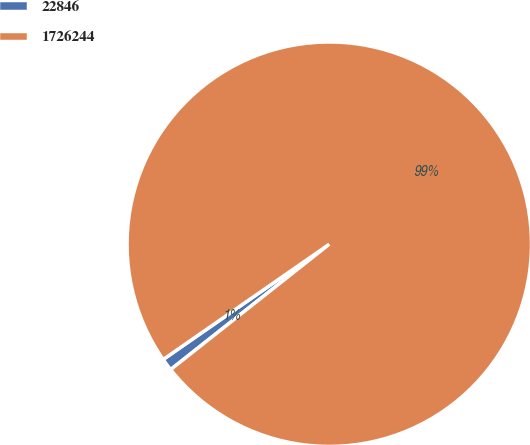Convert chart to OTSL. <chart><loc_0><loc_0><loc_500><loc_500><pie_chart><fcel>22846<fcel>1726244<nl><fcel>0.99%<fcel>99.01%<nl></chart> 